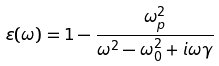<formula> <loc_0><loc_0><loc_500><loc_500>\varepsilon ( \omega ) = 1 - \frac { \omega _ { p } ^ { 2 } } { \omega ^ { 2 } - \omega _ { 0 } ^ { 2 } + i \omega \gamma }</formula> 